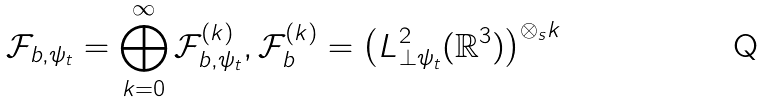<formula> <loc_0><loc_0><loc_500><loc_500>\mathcal { F } _ { b , \psi _ { t } } = \bigoplus _ { k = 0 } ^ { \infty } \mathcal { F } _ { b , \psi _ { t } } ^ { ( k ) } , \mathcal { F } _ { b } ^ { ( k ) } = \left ( L ^ { 2 } _ { \perp \psi _ { t } } ( \mathbb { R } ^ { 3 } ) \right ) ^ { \otimes _ { s } k }</formula> 